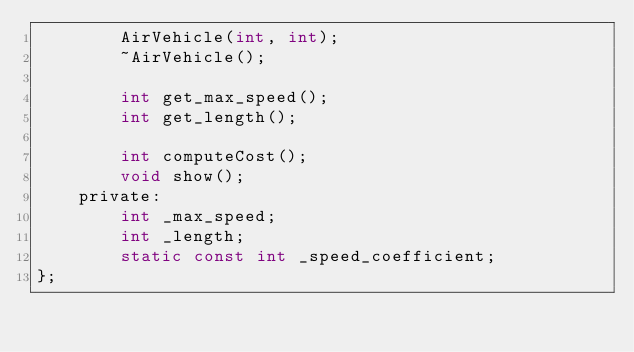<code> <loc_0><loc_0><loc_500><loc_500><_C_>		AirVehicle(int, int);
		~AirVehicle();

		int get_max_speed();
		int get_length();

		int computeCost();
		void show();
	private:
		int _max_speed;
		int _length;
		static const int _speed_coefficient;
};</code> 